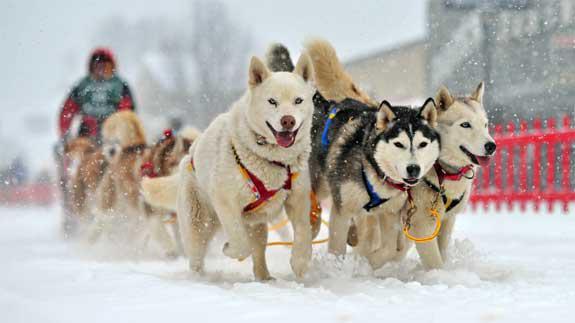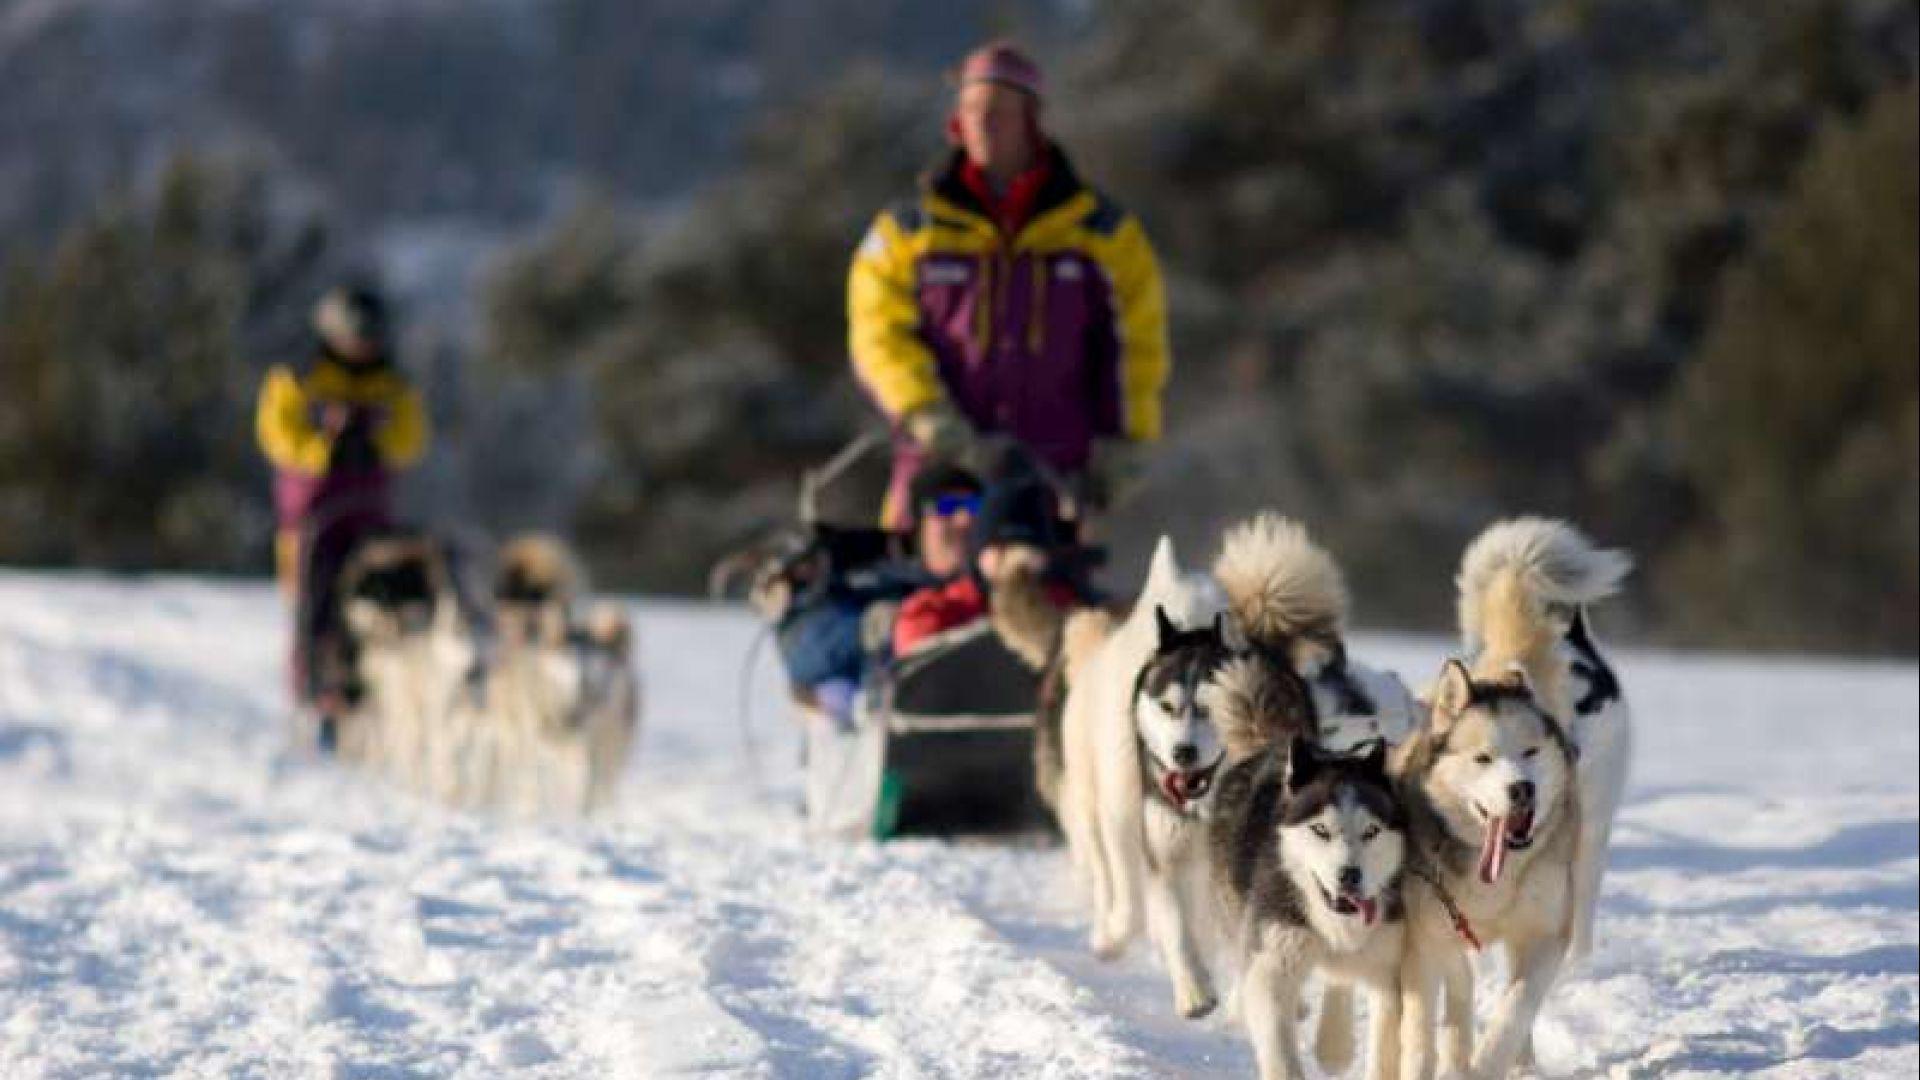The first image is the image on the left, the second image is the image on the right. Considering the images on both sides, is "In at least one image there are are at least five huskey moving left with doggy boots covering their paws." valid? Answer yes or no. No. The first image is the image on the left, the second image is the image on the right. Considering the images on both sides, is "The sled dogs in the images are running in the same general direction." valid? Answer yes or no. Yes. 